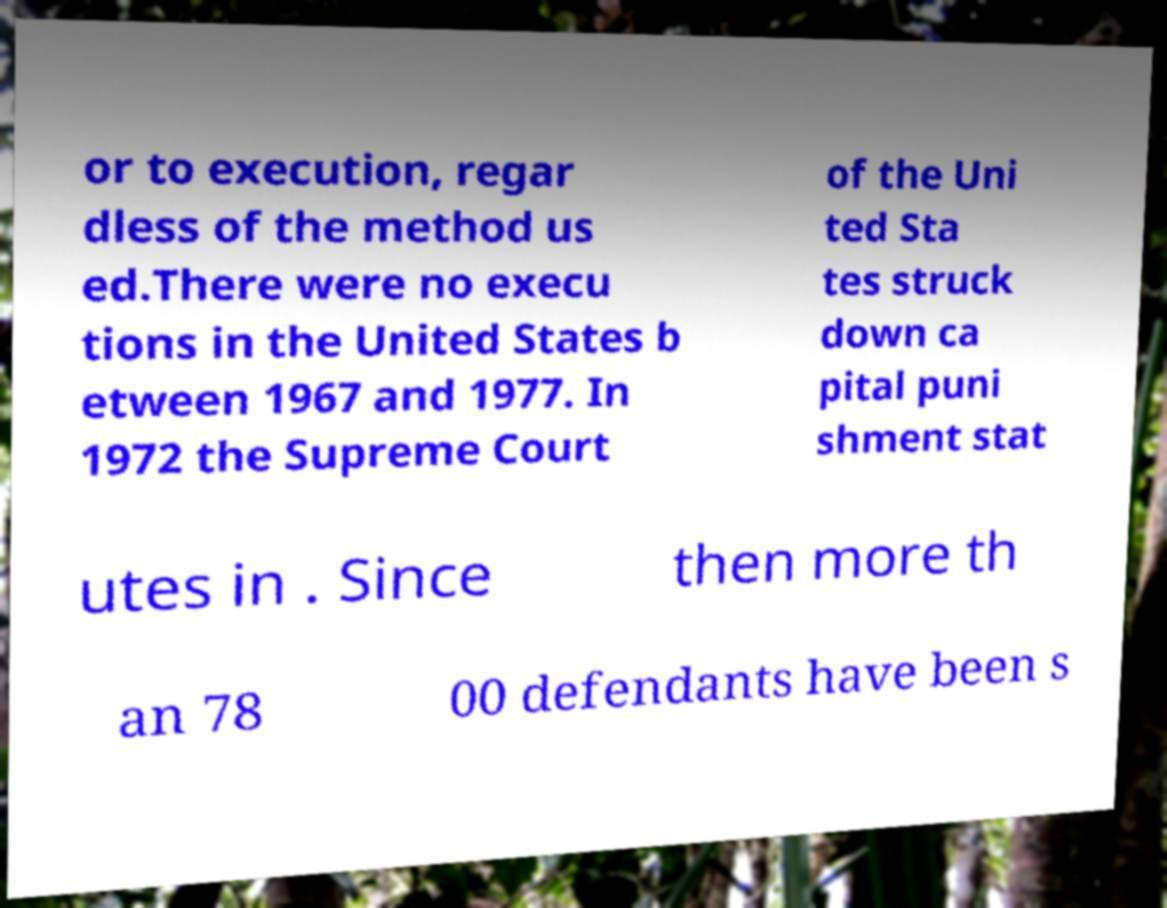What messages or text are displayed in this image? I need them in a readable, typed format. or to execution, regar dless of the method us ed.There were no execu tions in the United States b etween 1967 and 1977. In 1972 the Supreme Court of the Uni ted Sta tes struck down ca pital puni shment stat utes in . Since then more th an 78 00 defendants have been s 